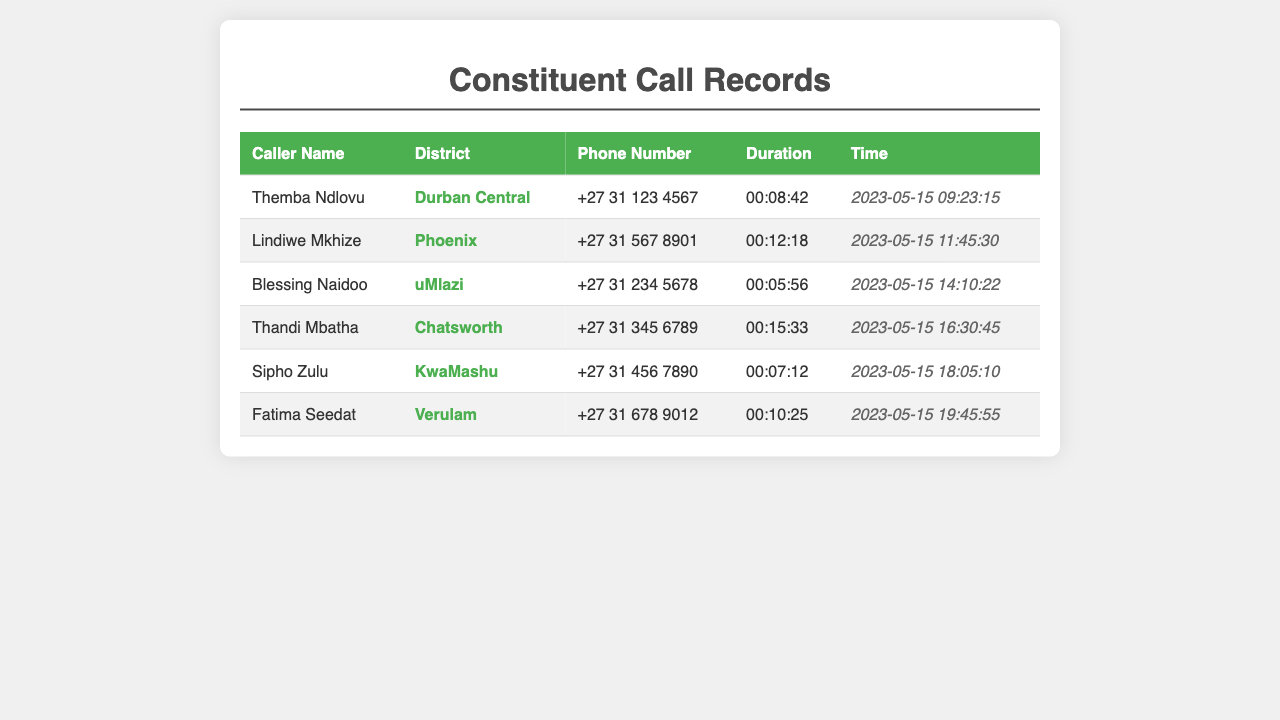What is the total number of incoming calls? The total number of incoming calls is determined by counting the number of entries in the table, which shows six calls.
Answer: 6 Who called from Durban Central? The caller from Durban Central is listed in the first row of the table, which identifies Themba Ndlovu as the caller.
Answer: Themba Ndlovu What is the phone number of Lindiwe Mkhize? The phone number is straightforwardly found in the row corresponding to Lindiwe Mkhize, which is the second entry.
Answer: +27 31 567 8901 How long did the call from Thandi Mbatha last? The duration of the call is indicated in the table under the Duration column for Thandi Mbatha.
Answer: 00:15:33 Which district received the shortest call? To find the shortest call, compare all durations in the Duration column, revealing that Blessing Naidoo's call was the briefest.
Answer: uMlazi At what time did Sipho Zulu call? The time of Sipho Zulu's call is specified in the corresponding row within the Time column.
Answer: 2023-05-15 18:05:10 Which caller had the longest duration? The longest call duration is determined by examining the table, and Thandi Mbatha has the longest at 15 minutes and 33 seconds.
Answer: Thandi Mbatha What is the average duration of all calls? The average duration can be calculated by adding all durations and dividing by the number of calls, leading to approximately 10 minutes and 8 seconds.
Answer: 00:10:08 Which two districts called at that time? The entries provide two distinct districts: uMlazi and Chatsworth, which made calls on the same day but at different times.
Answer: uMlazi, Chatsworth 